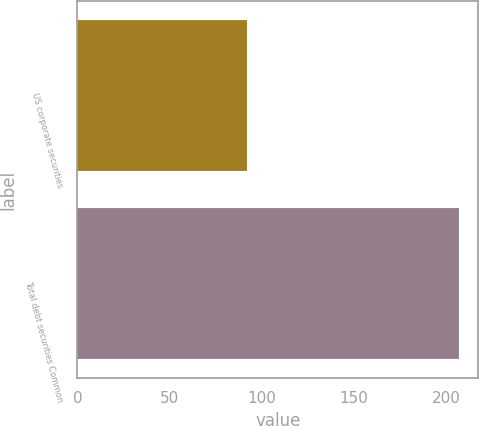Convert chart to OTSL. <chart><loc_0><loc_0><loc_500><loc_500><bar_chart><fcel>US corporate securities<fcel>Total debt securities Common<nl><fcel>92<fcel>207<nl></chart> 